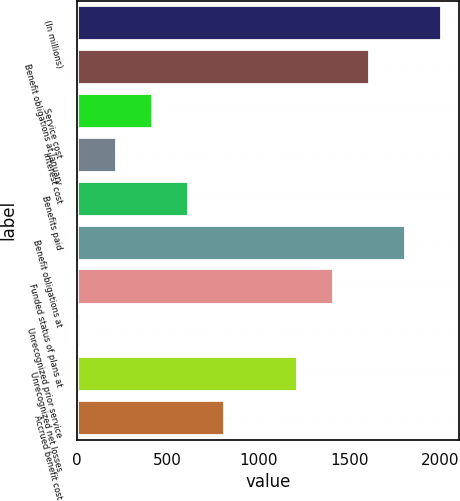Convert chart. <chart><loc_0><loc_0><loc_500><loc_500><bar_chart><fcel>(In millions)<fcel>Benefit obligations at January<fcel>Service cost<fcel>Interest cost<fcel>Benefits paid<fcel>Benefit obligations at<fcel>Funded status of plans at<fcel>Unrecognized prior service<fcel>Unrecognized net losses<fcel>Accrued benefit cost<nl><fcel>2004<fcel>1606.8<fcel>415.2<fcel>216.6<fcel>613.8<fcel>1805.4<fcel>1408.2<fcel>18<fcel>1209.6<fcel>812.4<nl></chart> 